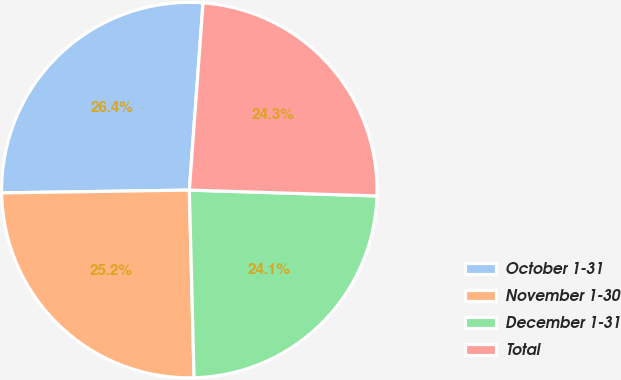Convert chart to OTSL. <chart><loc_0><loc_0><loc_500><loc_500><pie_chart><fcel>October 1-31<fcel>November 1-30<fcel>December 1-31<fcel>Total<nl><fcel>26.4%<fcel>25.16%<fcel>24.1%<fcel>24.33%<nl></chart> 